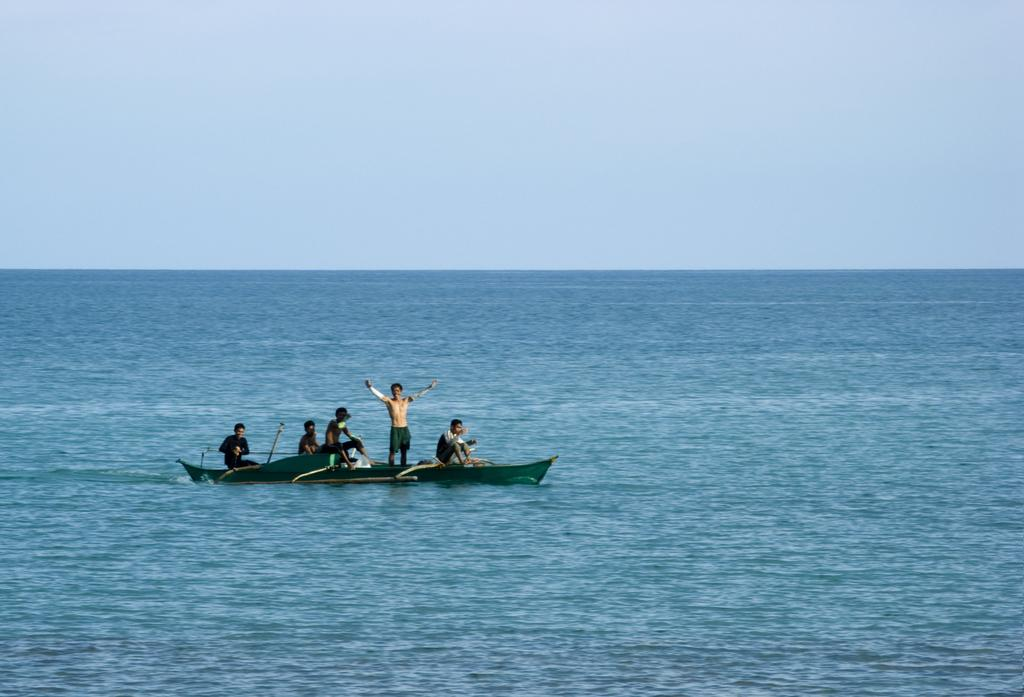What is the main subject of the image? The main subject of the image is a boat. Where is the boat located? The boat is on the water. Are there any people on the boat? Yes, there are people on the boat. What can be seen in the background of the image? There is sky visible in the background of the image. What type of pancake is being served on the boat in the image? There is no pancake present in the image; it features a boat on the water with people on board. 